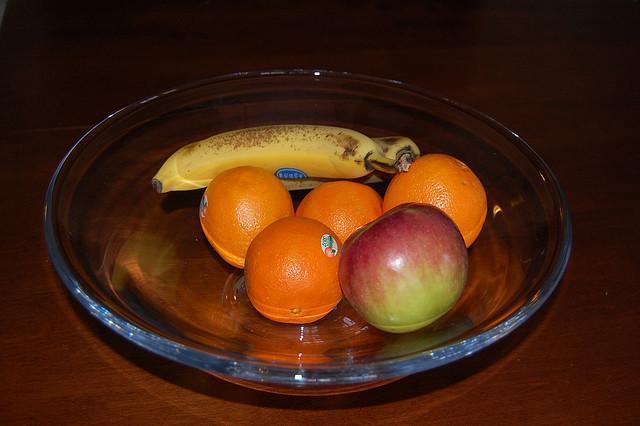How many kinds of fruit are there?
Give a very brief answer. 3. How many of these fruits can be eaten without removing the peel?
Give a very brief answer. 1. How many fruits are in the bowl?
Give a very brief answer. 7. How many types of fruits are shown?
Give a very brief answer. 3. How many oranges are in the picture?
Give a very brief answer. 4. 